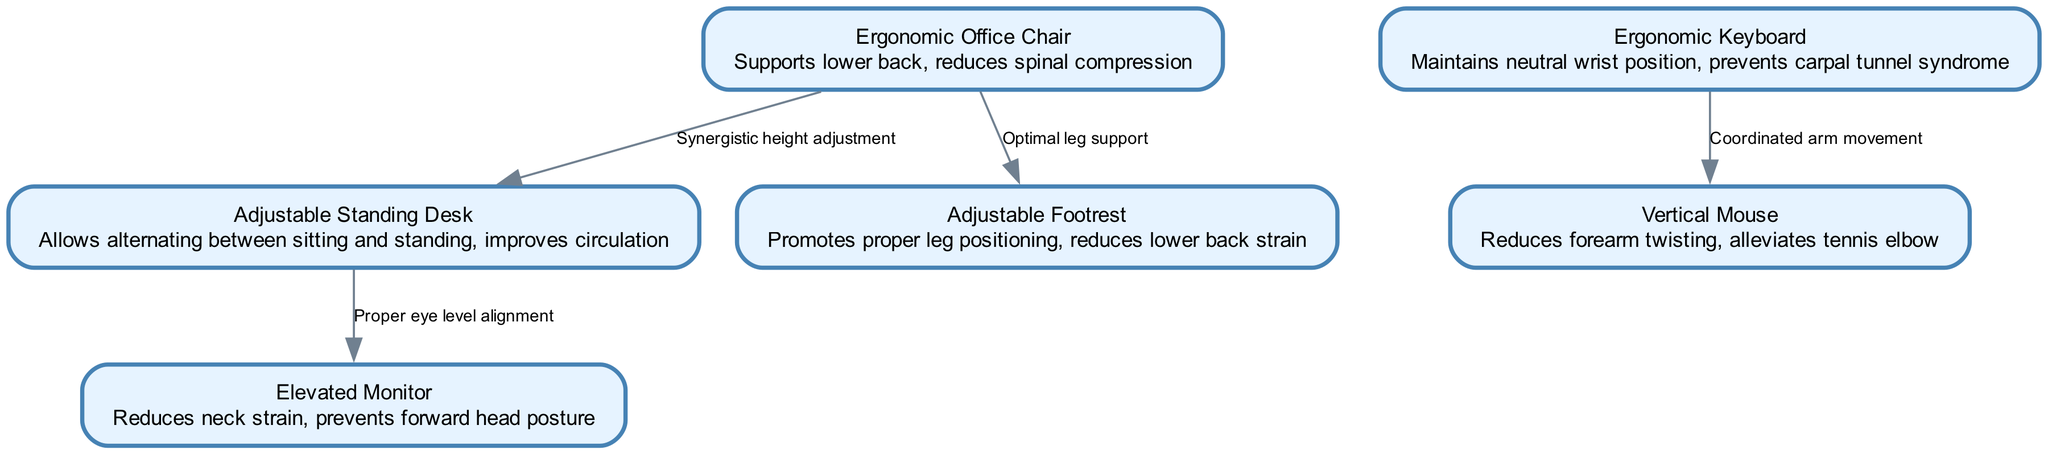What is the primary benefit of an ergonomic office chair? The diagram states that the ergonomic office chair "supports lower back, reduces spinal compression." This indicates that its main function is to provide support for the lower back and lessen spinal compression during prolonged sitting.
Answer: supports lower back, reduces spinal compression How many nodes are there in the diagram? Counting the nodes section, there are six elements listed: ergonomic office chair, adjustable standing desk, elevated monitor, ergonomic keyboard, vertical mouse, and adjustable footrest. This totals to six nodes.
Answer: 6 What is the relationship between the chair and the footrest? The edge between the chair and the footrest indicates "Optimal leg support." This describes the benefit of using these two components together, emphasizing how the footrest contributes to the leg positioning relative to the chair.
Answer: Optimal leg support Which item is linked to reduced neck strain? The diagram connects the elevated monitor as providing "reduces neck strain, prevents forward head posture." Therefore, the elevated monitor is specifically cited as linked to alleviating neck strain.
Answer: Elevated Monitor What is a benefit of using an adjustable standing desk? According to the description given in the diagram, the adjustable standing desk "allows alternating between sitting and standing, improves circulation." This means one of its main advantages is facilitating movement that enhances blood flow.
Answer: improves circulation Which two items are associated with coordinated arm movement? The diagram shows an edge labeled "Coordinated arm movement" connecting the ergonomic keyboard and vertical mouse. This indicates that these two items work together beneficially for arm positioning.
Answer: ergonomic keyboard and vertical mouse Why is an ergonomic keyboard important? The description in the diagram states that an ergonomic keyboard "maintains neutral wrist position, prevents carpal tunnel syndrome." This highlights its significance in promoting proper wrist alignment to prevent repetitive strain injuries.
Answer: prevents carpal tunnel syndrome What is the function of the adjustable footrest? The adjustable footrest is described in the diagram as promoting "proper leg positioning, reduces lower back strain." This defines its role in providing support to the legs and alleviating stress on the lower back.
Answer: reduces lower back strain 